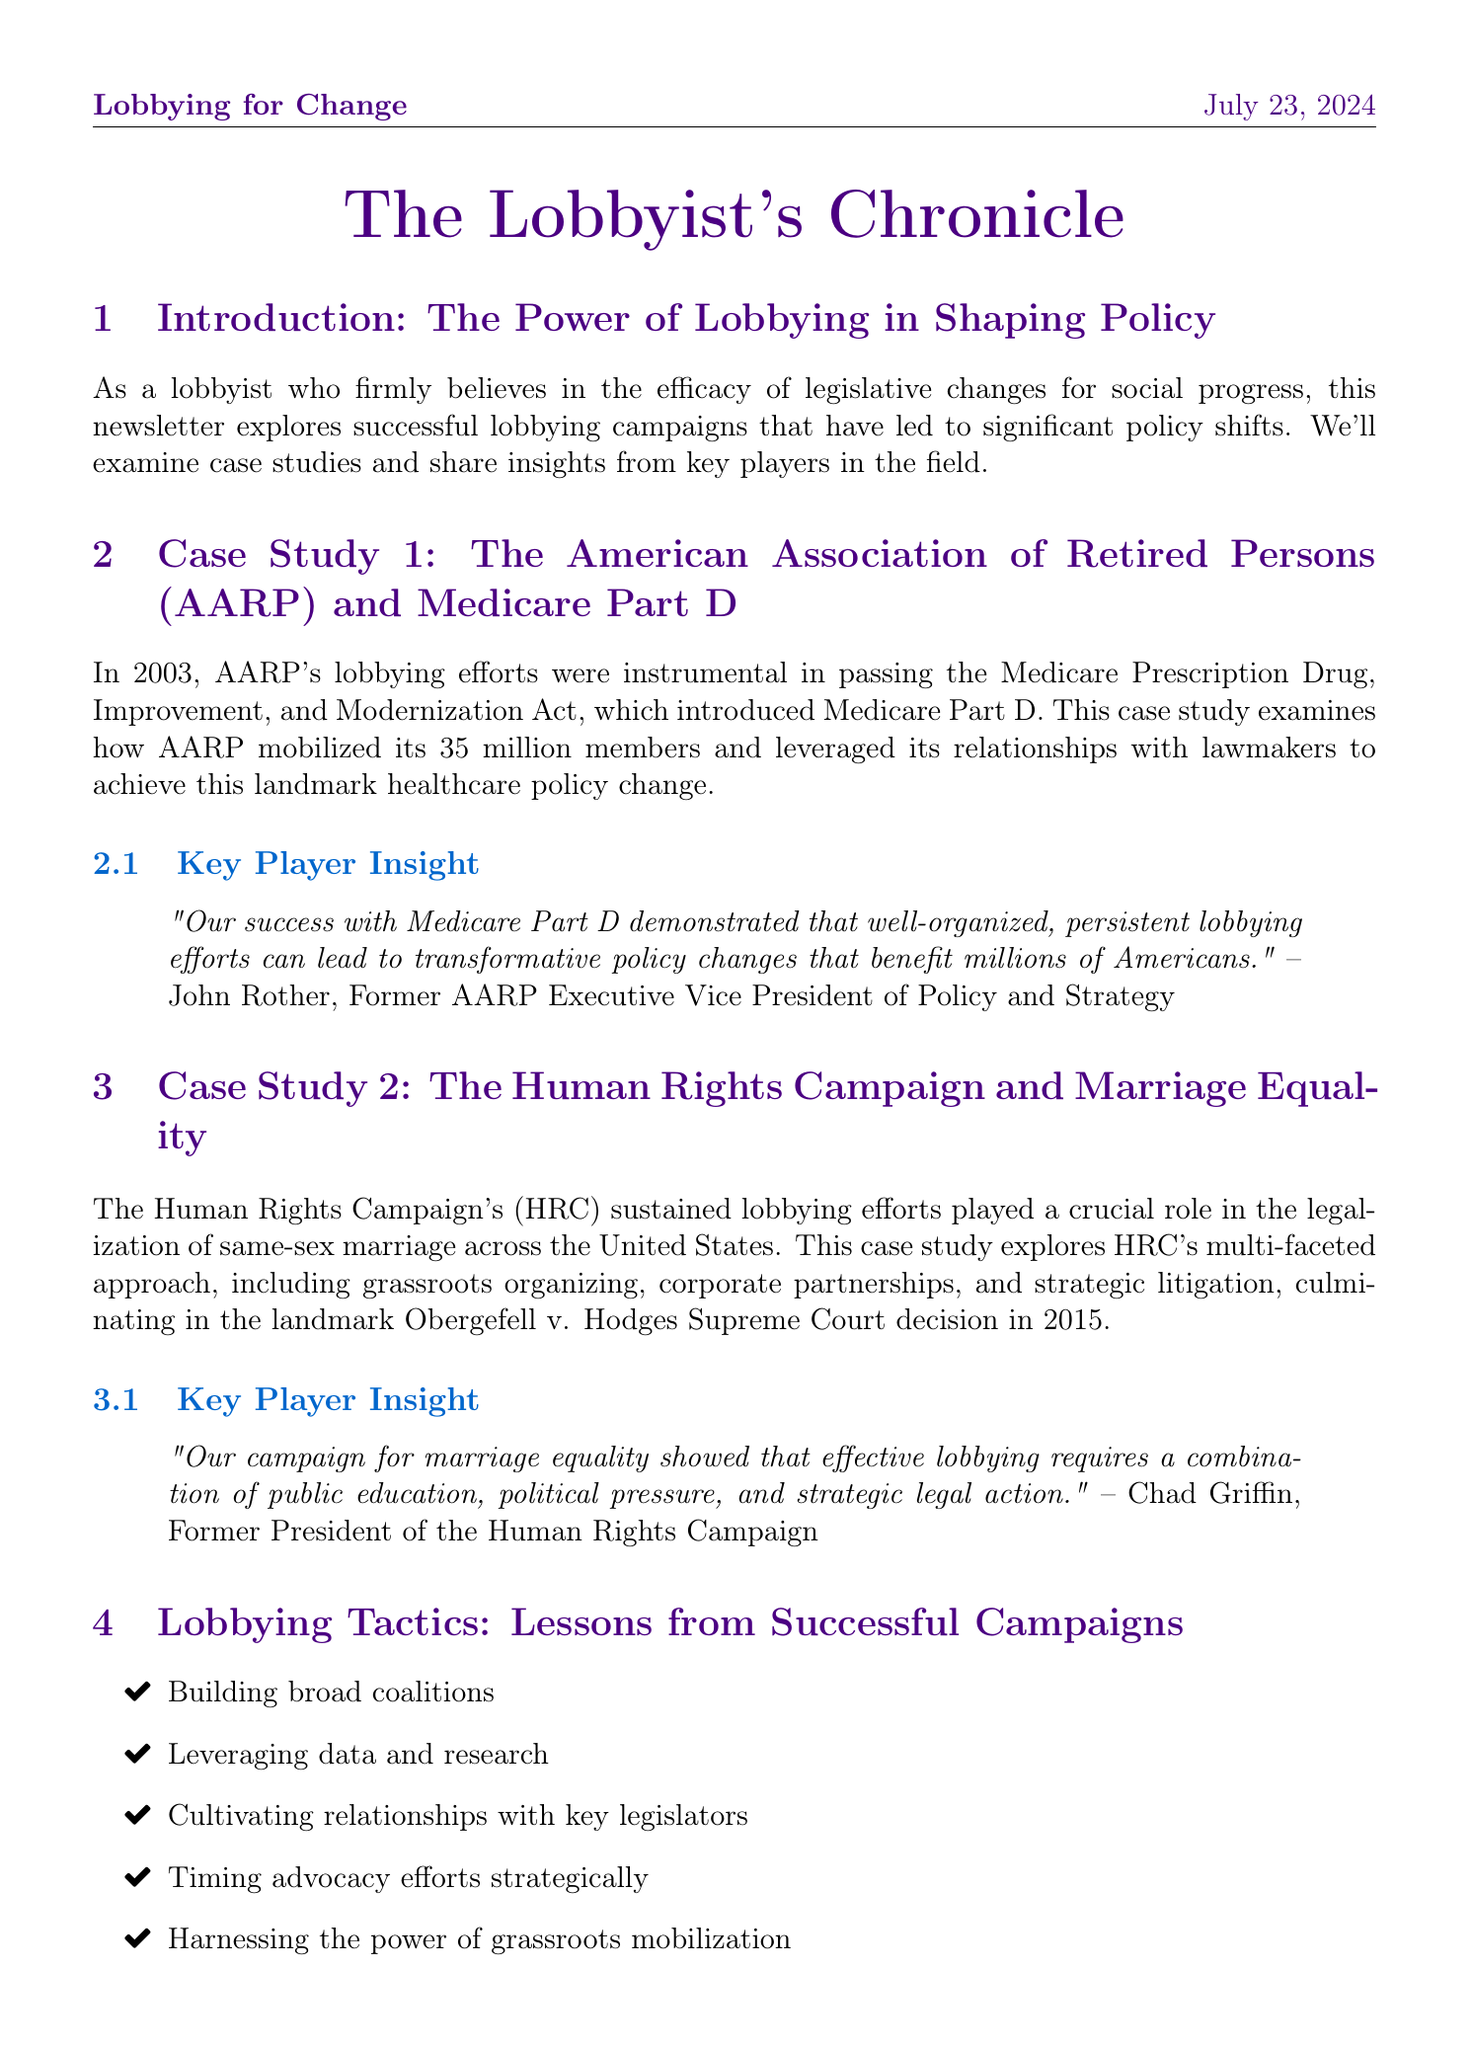What was the key legislation discussed in the AARP case study? The key legislation discussed is the Medicare Prescription Drug, Improvement, and Modernization Act.
Answer: Medicare Prescription Drug, Improvement, and Modernization Act Who was the key player interviewed in the AARP case study? The key player interviewed is John Rother, who was the Former AARP Executive Vice President of Policy and Strategy.
Answer: John Rother What was the significant Supreme Court decision related to the Human Rights Campaign? The significant Supreme Court decision related to the Human Rights Campaign is Obergefell v. Hodges.
Answer: Obergefell v. Hodges Which lobbying tactic emphasizes the importance of collaboration? The lobbying tactic that emphasizes the importance of collaboration is Building broad coalitions.
Answer: Building broad coalitions What was the main focus of the expert interview in the newsletter? The main focus of the expert interview was the evolving landscape of lobbying and its role in shaping future legislation.
Answer: The evolving landscape of lobbying and its role in shaping future legislation What year did the Medicare Part D program begin? The Medicare Part D program began in 2003.
Answer: 2003 How many members did AARP mobilize for their lobbying efforts? AARP mobilized 35 million members for their lobbying efforts.
Answer: 35 million What is one emerging topic discussed in the expert insight section? One emerging topic discussed is the increasing importance of digital advocacy.
Answer: The increasing importance of digital advocacy 